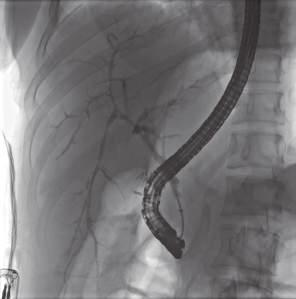s a nucleolar pattern entrapped in a dense, onion-skin concentric scar?
Answer the question using a single word or phrase. No 